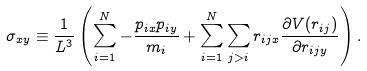<formula> <loc_0><loc_0><loc_500><loc_500>\sigma _ { x y } \equiv \frac { 1 } { L ^ { 3 } } \left ( \sum _ { i = 1 } ^ { N } - \frac { p _ { i x } p _ { i y } } { m _ { i } } + \sum _ { i = 1 } ^ { N } \sum _ { j > i } r _ { i j x } \frac { \partial V ( r _ { i j } ) } { \partial r _ { i j y } } \right ) .</formula> 